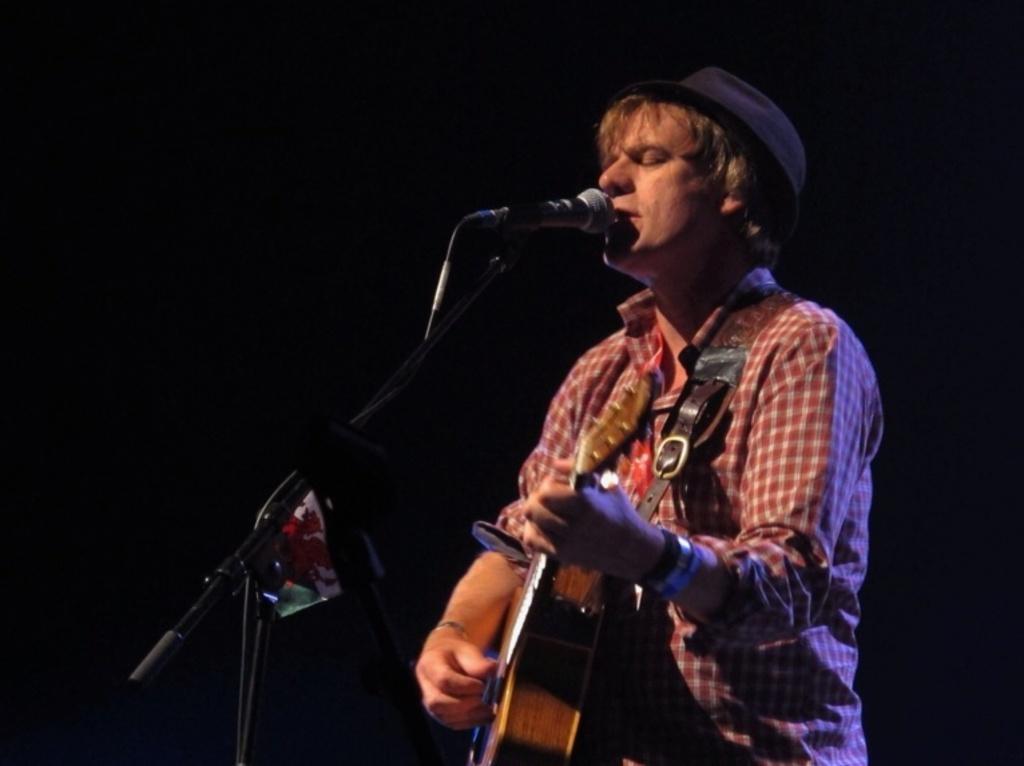What is the man in the image doing? The man is playing a guitar and singing. What is the man wearing on his upper body? The man is wearing a checkered shirt. What accessory is the man wearing on his head? The man is wearing a hat. What equipment is present in the image for amplifying the man's voice? There is a mic stand and a microphone in the image. How many kittens are playing with a pencil on the man's hat in the image? There are no kittens or pencils present in the image, and therefore no such activity can be observed. 